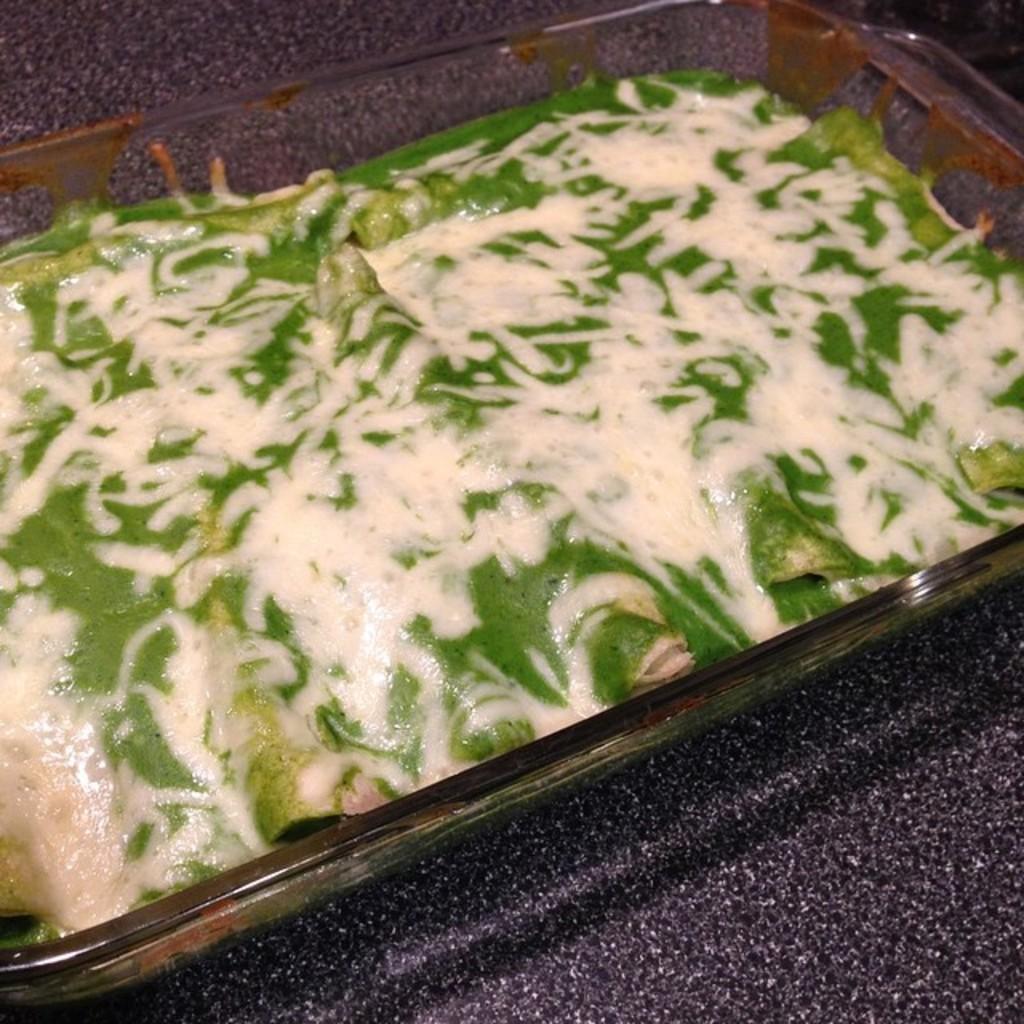In one or two sentences, can you explain what this image depicts? In this picture there is food in the bowl. At the bottom it looks like a marble. 